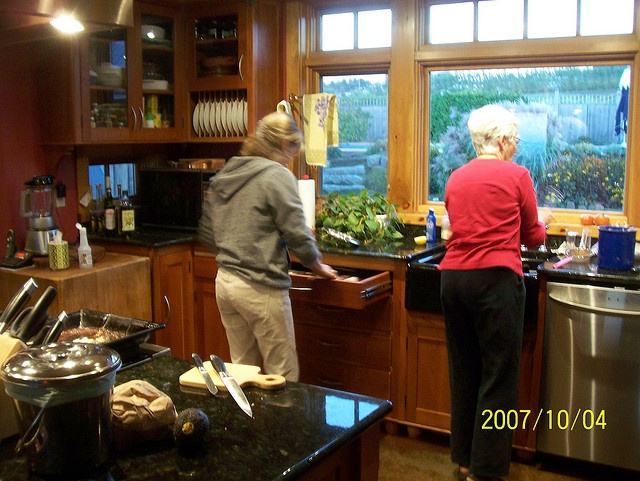Describe the objects in this image and their specific colors. I can see dining table in black, olive, maroon, and khaki tones, people in black, brown, and salmon tones, people in black, gray, and tan tones, oven in black and gray tones, and microwave in black, maroon, and gray tones in this image. 